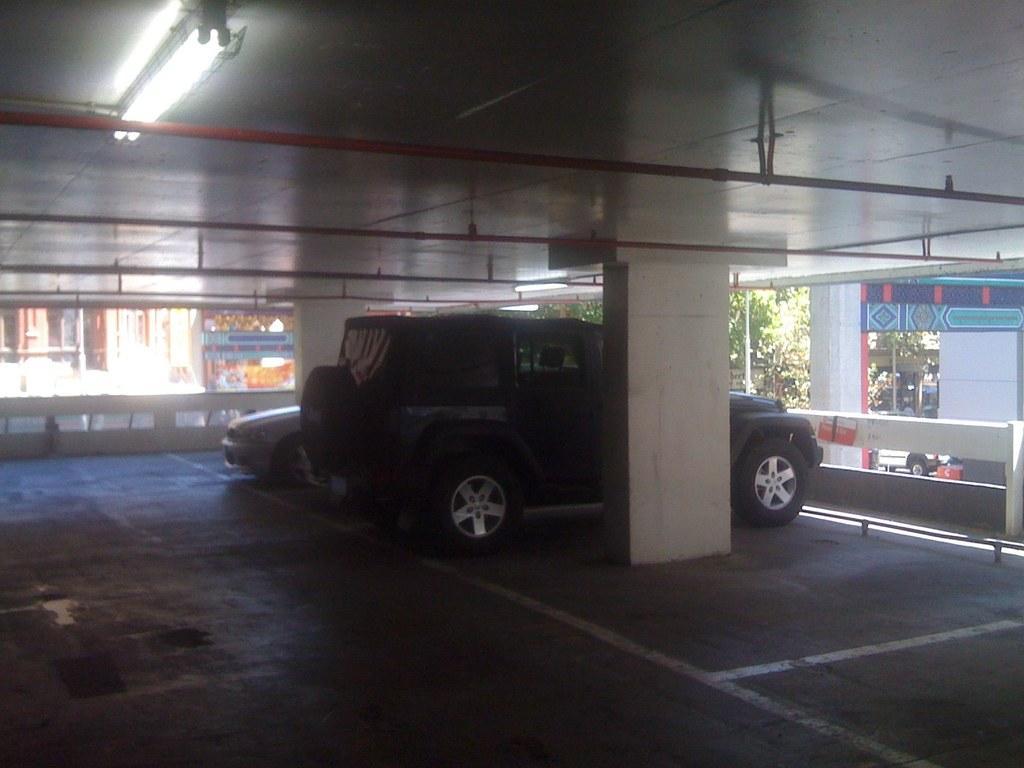Describe this image in one or two sentences. There are vehicles and a pillar in the foreground area of the image, there is a poster, buildings and trees in the background and a light at the top side. 